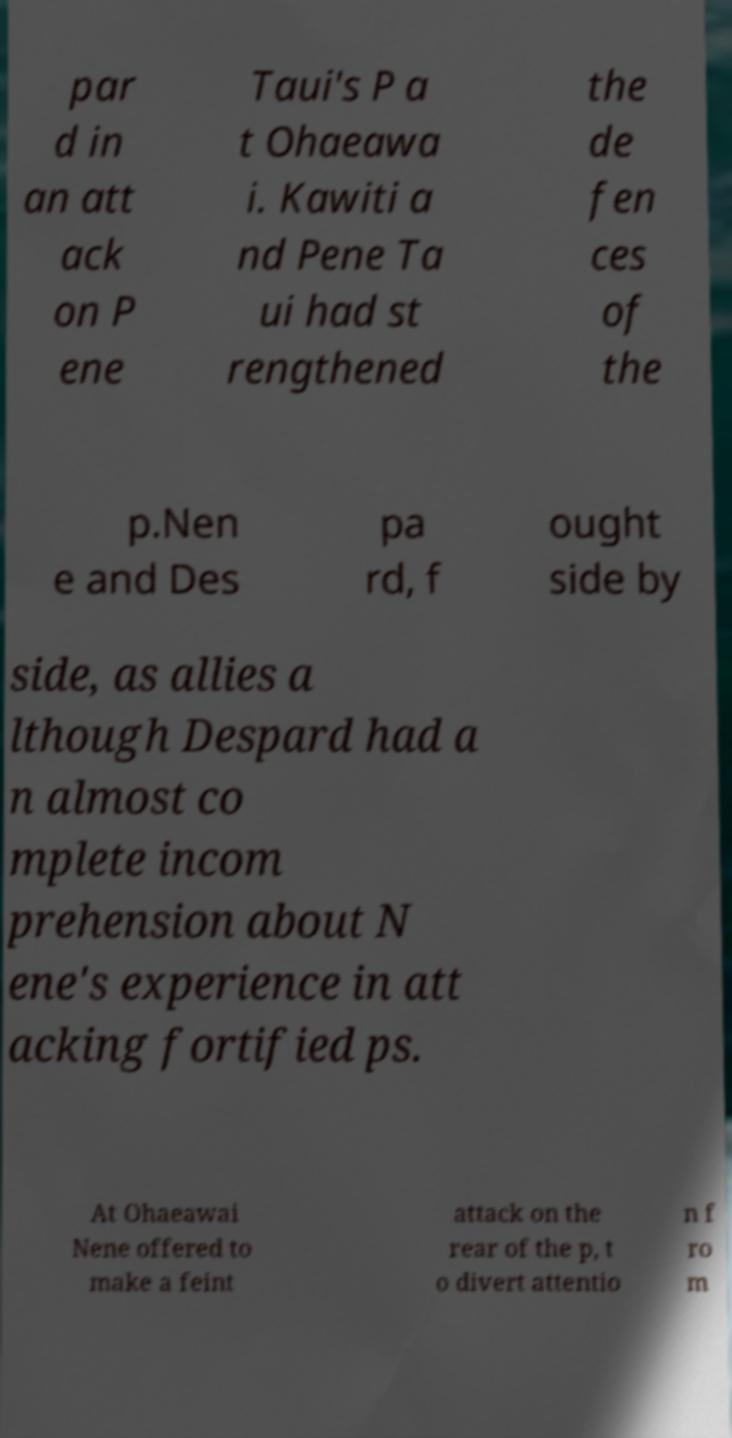Could you extract and type out the text from this image? par d in an att ack on P ene Taui's P a t Ohaeawa i. Kawiti a nd Pene Ta ui had st rengthened the de fen ces of the p.Nen e and Des pa rd, f ought side by side, as allies a lthough Despard had a n almost co mplete incom prehension about N ene's experience in att acking fortified ps. At Ohaeawai Nene offered to make a feint attack on the rear of the p, t o divert attentio n f ro m 